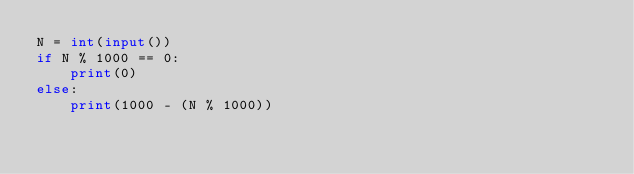Convert code to text. <code><loc_0><loc_0><loc_500><loc_500><_Python_>N = int(input())
if N % 1000 == 0:
    print(0)
else:
    print(1000 - (N % 1000))
</code> 